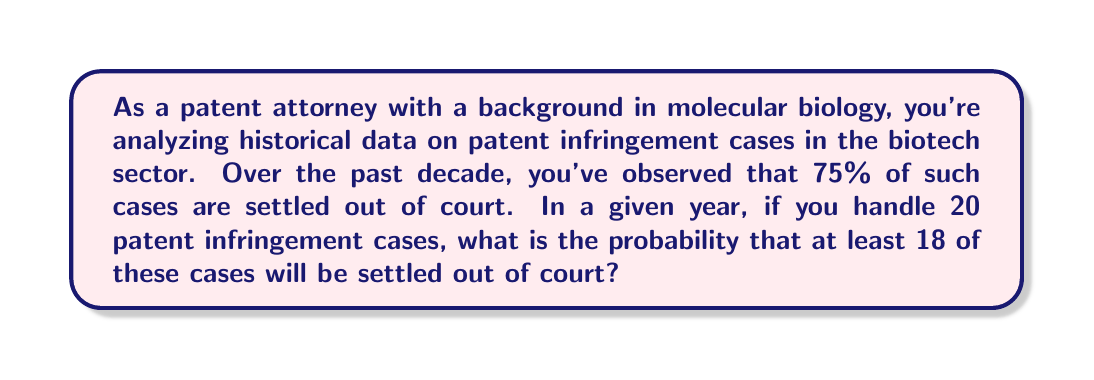Provide a solution to this math problem. To solve this problem, we'll use the binomial probability distribution, as we're dealing with a fixed number of independent trials (cases) with two possible outcomes (settled out of court or not).

Let's define our variables:
$n = 20$ (total number of cases)
$p = 0.75$ (probability of a case being settled out of court)
$q = 1 - p = 0.25$ (probability of a case not being settled out of court)

We need to find the probability of 18, 19, or 20 cases being settled out of court.

The probability mass function for a binomial distribution is:

$$P(X = k) = \binom{n}{k} p^k q^{n-k}$$

Where $\binom{n}{k}$ is the binomial coefficient, calculated as:

$$\binom{n}{k} = \frac{n!}{k!(n-k)!}$$

We need to calculate:

$$P(X \geq 18) = P(X = 18) + P(X = 19) + P(X = 20)$$

For $k = 18$:
$$P(X = 18) = \binom{20}{18} (0.75)^{18} (0.25)^{2} = 190 \cdot 0.75^{18} \cdot 0.25^2 \approx 0.2252$$

For $k = 19$:
$$P(X = 19) = \binom{20}{19} (0.75)^{19} (0.25)^{1} = 20 \cdot 0.75^{19} \cdot 0.25 \approx 0.1001$$

For $k = 20$:
$$P(X = 20) = \binom{20}{20} (0.75)^{20} (0.25)^{0} = 1 \cdot 0.75^{20} \approx 0.0032$$

Sum these probabilities:

$$P(X \geq 18) = 0.2252 + 0.1001 + 0.0032 \approx 0.3285$$
Answer: The probability that at least 18 out of 20 patent infringement cases will be settled out of court is approximately 0.3285 or 32.85%. 